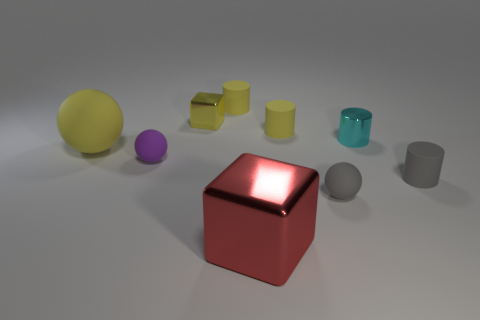Subtract all red balls. How many yellow cylinders are left? 2 Subtract all small gray matte cylinders. How many cylinders are left? 3 Subtract all gray cylinders. How many cylinders are left? 3 Subtract 1 balls. How many balls are left? 2 Subtract all blue cylinders. Subtract all red spheres. How many cylinders are left? 4 Add 1 metallic things. How many objects exist? 10 Subtract all cylinders. How many objects are left? 5 Subtract all matte objects. Subtract all small gray things. How many objects are left? 1 Add 1 gray balls. How many gray balls are left? 2 Add 9 small gray cylinders. How many small gray cylinders exist? 10 